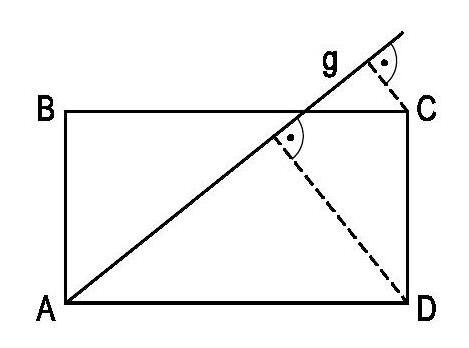Can you explain why line g is parallel to line CD in the diagram? Certainly! In the diagram, the straight line g passes through the vertex A of the rectangle ABCD. Since the opposite sides of a rectangle are parallel and of equal length, and since line g intersects AD at a right angle (implied by the perpendicular distances to C and D), it can be inferred that line g is parallel to line CD. 